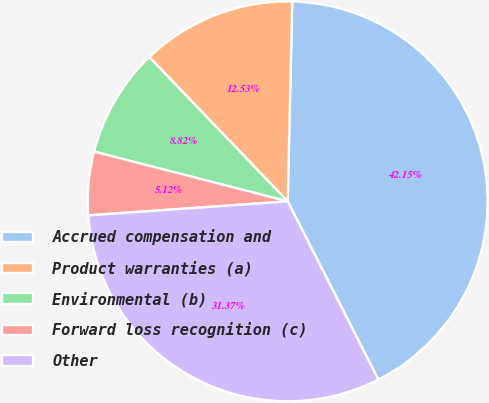Convert chart to OTSL. <chart><loc_0><loc_0><loc_500><loc_500><pie_chart><fcel>Accrued compensation and<fcel>Product warranties (a)<fcel>Environmental (b)<fcel>Forward loss recognition (c)<fcel>Other<nl><fcel>42.15%<fcel>12.53%<fcel>8.82%<fcel>5.12%<fcel>31.37%<nl></chart> 